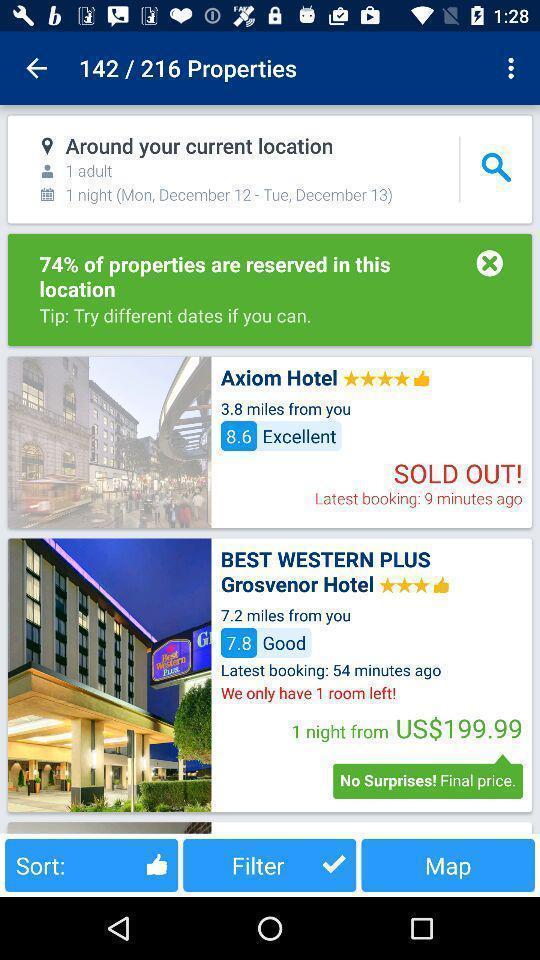Describe the content in this image. Page showing hotel booking app. 